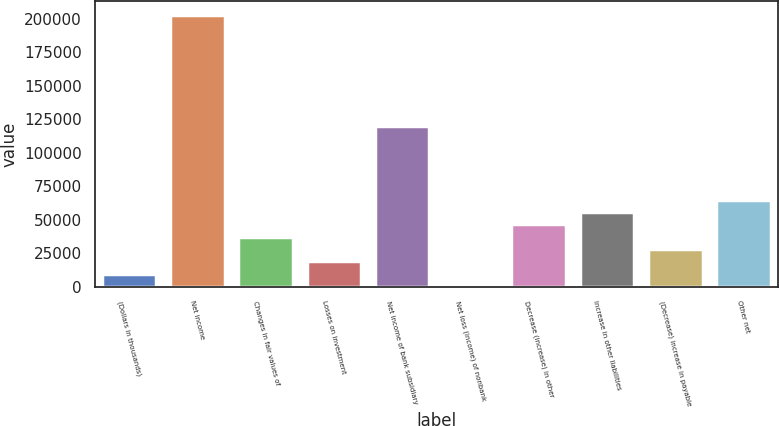<chart> <loc_0><loc_0><loc_500><loc_500><bar_chart><fcel>(Dollars in thousands)<fcel>Net income<fcel>Changes in fair values of<fcel>Losses on investment<fcel>Net income of bank subsidiary<fcel>Net loss (income) of nonbank<fcel>Decrease (increase) in other<fcel>Increase in other liabilities<fcel>(Decrease) increase in payable<fcel>Other net<nl><fcel>9944<fcel>202661<fcel>37475<fcel>19121<fcel>120068<fcel>767<fcel>46652<fcel>55829<fcel>28298<fcel>65006<nl></chart> 